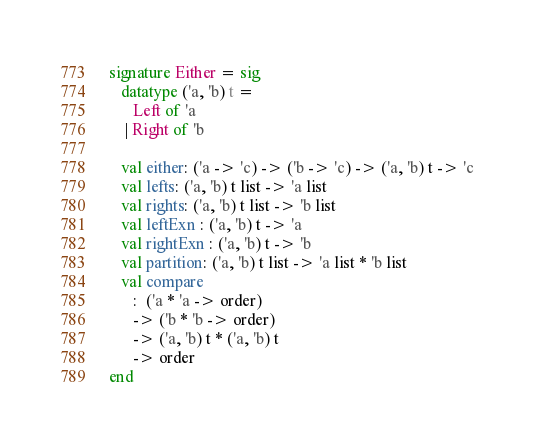Convert code to text. <code><loc_0><loc_0><loc_500><loc_500><_SML_>
signature Either = sig
   datatype ('a, 'b) t =
      Left of 'a
    | Right of 'b

   val either: ('a -> 'c) -> ('b -> 'c) -> ('a, 'b) t -> 'c
   val lefts: ('a, 'b) t list -> 'a list
   val rights: ('a, 'b) t list -> 'b list
   val leftExn : ('a, 'b) t -> 'a
   val rightExn : ('a, 'b) t -> 'b
   val partition: ('a, 'b) t list -> 'a list * 'b list
   val compare
      :  ('a * 'a -> order)
      -> ('b * 'b -> order)
      -> ('a, 'b) t * ('a, 'b) t
      -> order
end
</code> 